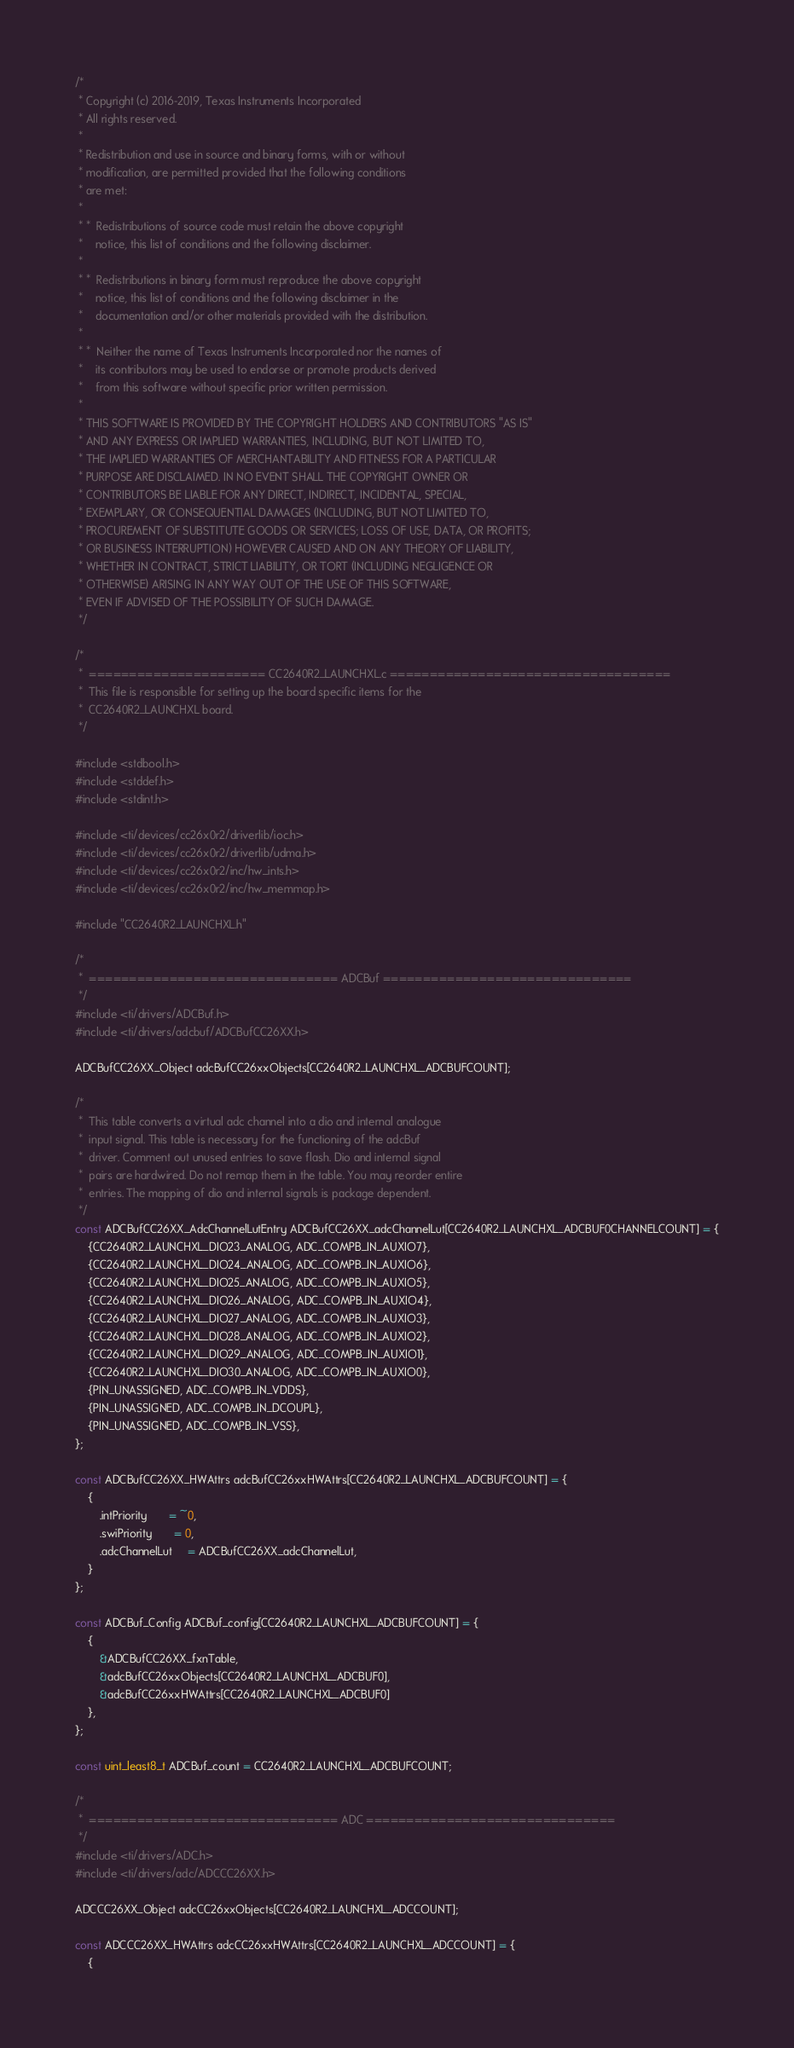Convert code to text. <code><loc_0><loc_0><loc_500><loc_500><_C_>/*
 * Copyright (c) 2016-2019, Texas Instruments Incorporated
 * All rights reserved.
 *
 * Redistribution and use in source and binary forms, with or without
 * modification, are permitted provided that the following conditions
 * are met:
 *
 * *  Redistributions of source code must retain the above copyright
 *    notice, this list of conditions and the following disclaimer.
 *
 * *  Redistributions in binary form must reproduce the above copyright
 *    notice, this list of conditions and the following disclaimer in the
 *    documentation and/or other materials provided with the distribution.
 *
 * *  Neither the name of Texas Instruments Incorporated nor the names of
 *    its contributors may be used to endorse or promote products derived
 *    from this software without specific prior written permission.
 *
 * THIS SOFTWARE IS PROVIDED BY THE COPYRIGHT HOLDERS AND CONTRIBUTORS "AS IS"
 * AND ANY EXPRESS OR IMPLIED WARRANTIES, INCLUDING, BUT NOT LIMITED TO,
 * THE IMPLIED WARRANTIES OF MERCHANTABILITY AND FITNESS FOR A PARTICULAR
 * PURPOSE ARE DISCLAIMED. IN NO EVENT SHALL THE COPYRIGHT OWNER OR
 * CONTRIBUTORS BE LIABLE FOR ANY DIRECT, INDIRECT, INCIDENTAL, SPECIAL,
 * EXEMPLARY, OR CONSEQUENTIAL DAMAGES (INCLUDING, BUT NOT LIMITED TO,
 * PROCUREMENT OF SUBSTITUTE GOODS OR SERVICES; LOSS OF USE, DATA, OR PROFITS;
 * OR BUSINESS INTERRUPTION) HOWEVER CAUSED AND ON ANY THEORY OF LIABILITY,
 * WHETHER IN CONTRACT, STRICT LIABILITY, OR TORT (INCLUDING NEGLIGENCE OR
 * OTHERWISE) ARISING IN ANY WAY OUT OF THE USE OF THIS SOFTWARE,
 * EVEN IF ADVISED OF THE POSSIBILITY OF SUCH DAMAGE.
 */

/*
 *  ====================== CC2640R2_LAUNCHXL.c ===================================
 *  This file is responsible for setting up the board specific items for the
 *  CC2640R2_LAUNCHXL board.
 */

#include <stdbool.h>
#include <stddef.h>
#include <stdint.h>

#include <ti/devices/cc26x0r2/driverlib/ioc.h>
#include <ti/devices/cc26x0r2/driverlib/udma.h>
#include <ti/devices/cc26x0r2/inc/hw_ints.h>
#include <ti/devices/cc26x0r2/inc/hw_memmap.h>

#include "CC2640R2_LAUNCHXL.h"

/*
 *  =============================== ADCBuf ===============================
 */
#include <ti/drivers/ADCBuf.h>
#include <ti/drivers/adcbuf/ADCBufCC26XX.h>

ADCBufCC26XX_Object adcBufCC26xxObjects[CC2640R2_LAUNCHXL_ADCBUFCOUNT];

/*
 *  This table converts a virtual adc channel into a dio and internal analogue
 *  input signal. This table is necessary for the functioning of the adcBuf
 *  driver. Comment out unused entries to save flash. Dio and internal signal
 *  pairs are hardwired. Do not remap them in the table. You may reorder entire
 *  entries. The mapping of dio and internal signals is package dependent.
 */
const ADCBufCC26XX_AdcChannelLutEntry ADCBufCC26XX_adcChannelLut[CC2640R2_LAUNCHXL_ADCBUF0CHANNELCOUNT] = {
    {CC2640R2_LAUNCHXL_DIO23_ANALOG, ADC_COMPB_IN_AUXIO7},
    {CC2640R2_LAUNCHXL_DIO24_ANALOG, ADC_COMPB_IN_AUXIO6},
    {CC2640R2_LAUNCHXL_DIO25_ANALOG, ADC_COMPB_IN_AUXIO5},
    {CC2640R2_LAUNCHXL_DIO26_ANALOG, ADC_COMPB_IN_AUXIO4},
    {CC2640R2_LAUNCHXL_DIO27_ANALOG, ADC_COMPB_IN_AUXIO3},
    {CC2640R2_LAUNCHXL_DIO28_ANALOG, ADC_COMPB_IN_AUXIO2},
    {CC2640R2_LAUNCHXL_DIO29_ANALOG, ADC_COMPB_IN_AUXIO1},
    {CC2640R2_LAUNCHXL_DIO30_ANALOG, ADC_COMPB_IN_AUXIO0},
    {PIN_UNASSIGNED, ADC_COMPB_IN_VDDS},
    {PIN_UNASSIGNED, ADC_COMPB_IN_DCOUPL},
    {PIN_UNASSIGNED, ADC_COMPB_IN_VSS},
};

const ADCBufCC26XX_HWAttrs adcBufCC26xxHWAttrs[CC2640R2_LAUNCHXL_ADCBUFCOUNT] = {
    {
        .intPriority       = ~0,
        .swiPriority       = 0,
        .adcChannelLut     = ADCBufCC26XX_adcChannelLut,
    }
};

const ADCBuf_Config ADCBuf_config[CC2640R2_LAUNCHXL_ADCBUFCOUNT] = {
    {
        &ADCBufCC26XX_fxnTable,
        &adcBufCC26xxObjects[CC2640R2_LAUNCHXL_ADCBUF0],
        &adcBufCC26xxHWAttrs[CC2640R2_LAUNCHXL_ADCBUF0]
    },
};

const uint_least8_t ADCBuf_count = CC2640R2_LAUNCHXL_ADCBUFCOUNT;

/*
 *  =============================== ADC ===============================
 */
#include <ti/drivers/ADC.h>
#include <ti/drivers/adc/ADCCC26XX.h>

ADCCC26XX_Object adcCC26xxObjects[CC2640R2_LAUNCHXL_ADCCOUNT];

const ADCCC26XX_HWAttrs adcCC26xxHWAttrs[CC2640R2_LAUNCHXL_ADCCOUNT] = {
    {</code> 